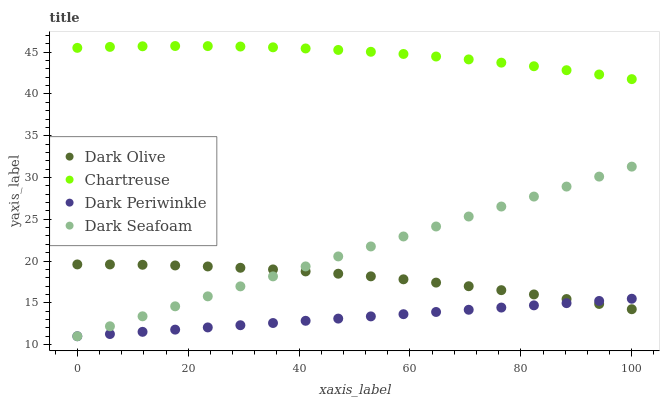Does Dark Periwinkle have the minimum area under the curve?
Answer yes or no. Yes. Does Chartreuse have the maximum area under the curve?
Answer yes or no. Yes. Does Dark Olive have the minimum area under the curve?
Answer yes or no. No. Does Dark Olive have the maximum area under the curve?
Answer yes or no. No. Is Dark Periwinkle the smoothest?
Answer yes or no. Yes. Is Chartreuse the roughest?
Answer yes or no. Yes. Is Dark Olive the smoothest?
Answer yes or no. No. Is Dark Olive the roughest?
Answer yes or no. No. Does Dark Periwinkle have the lowest value?
Answer yes or no. Yes. Does Dark Olive have the lowest value?
Answer yes or no. No. Does Chartreuse have the highest value?
Answer yes or no. Yes. Does Dark Olive have the highest value?
Answer yes or no. No. Is Dark Olive less than Chartreuse?
Answer yes or no. Yes. Is Chartreuse greater than Dark Seafoam?
Answer yes or no. Yes. Does Dark Periwinkle intersect Dark Olive?
Answer yes or no. Yes. Is Dark Periwinkle less than Dark Olive?
Answer yes or no. No. Is Dark Periwinkle greater than Dark Olive?
Answer yes or no. No. Does Dark Olive intersect Chartreuse?
Answer yes or no. No. 